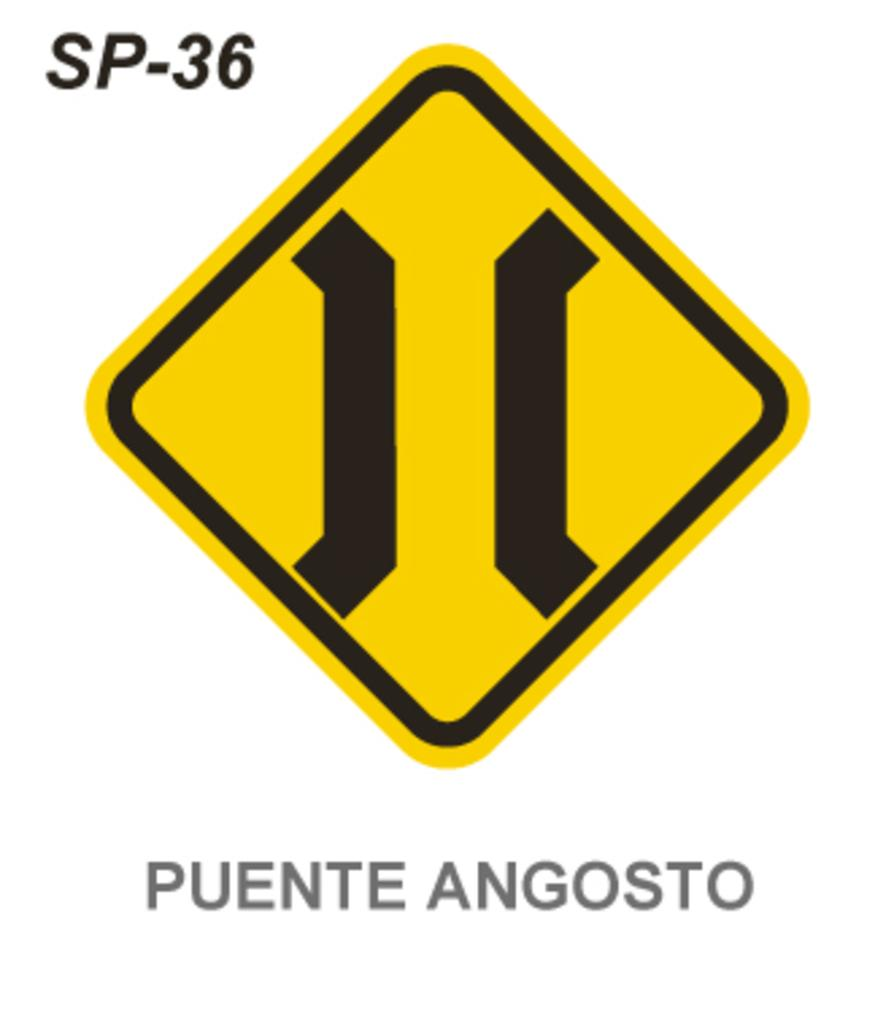<image>
Describe the image concisely. A yellow sign is above the text "Puente Angosto" 